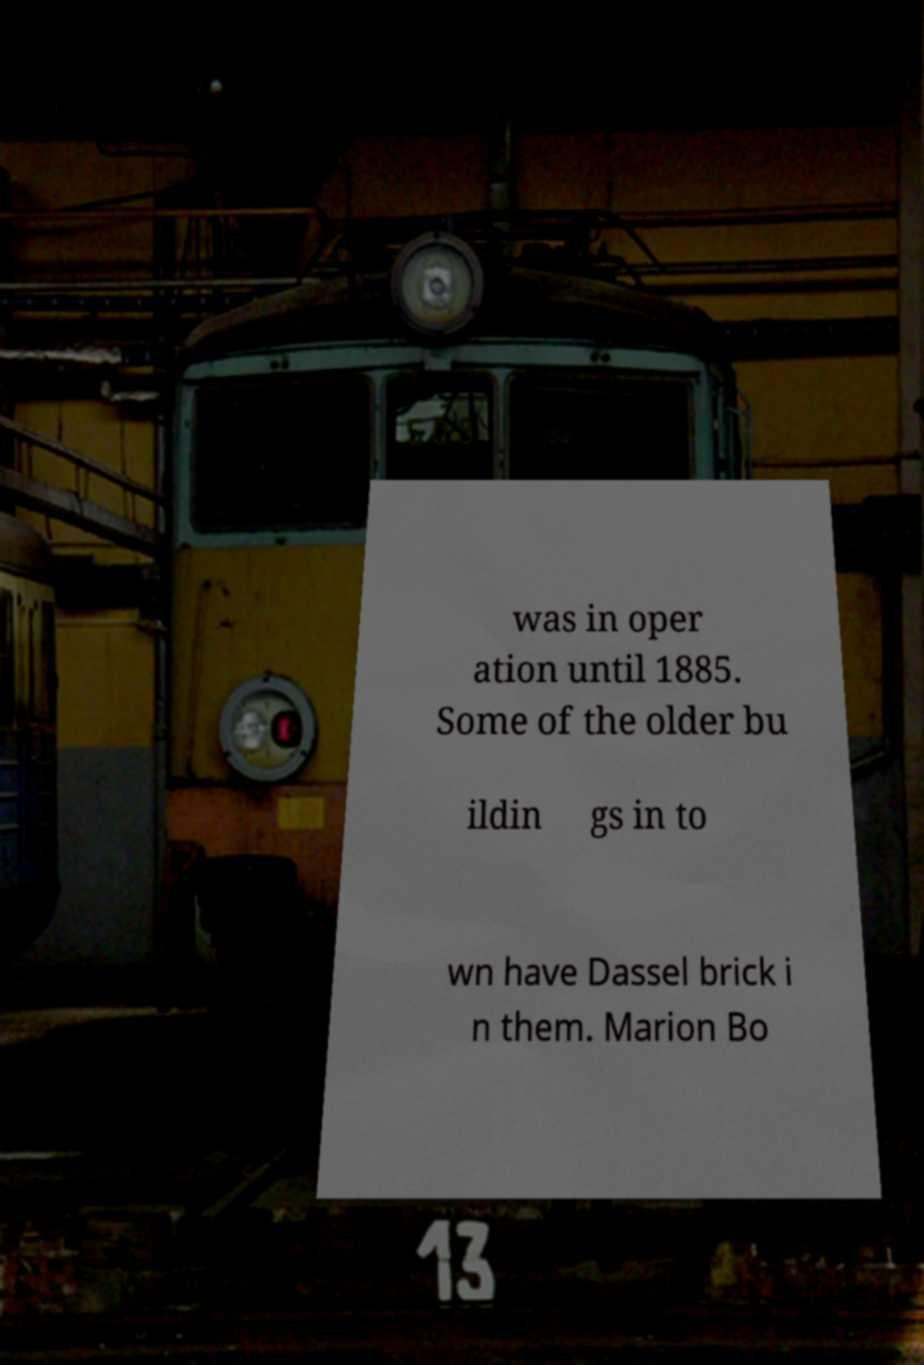I need the written content from this picture converted into text. Can you do that? was in oper ation until 1885. Some of the older bu ildin gs in to wn have Dassel brick i n them. Marion Bo 